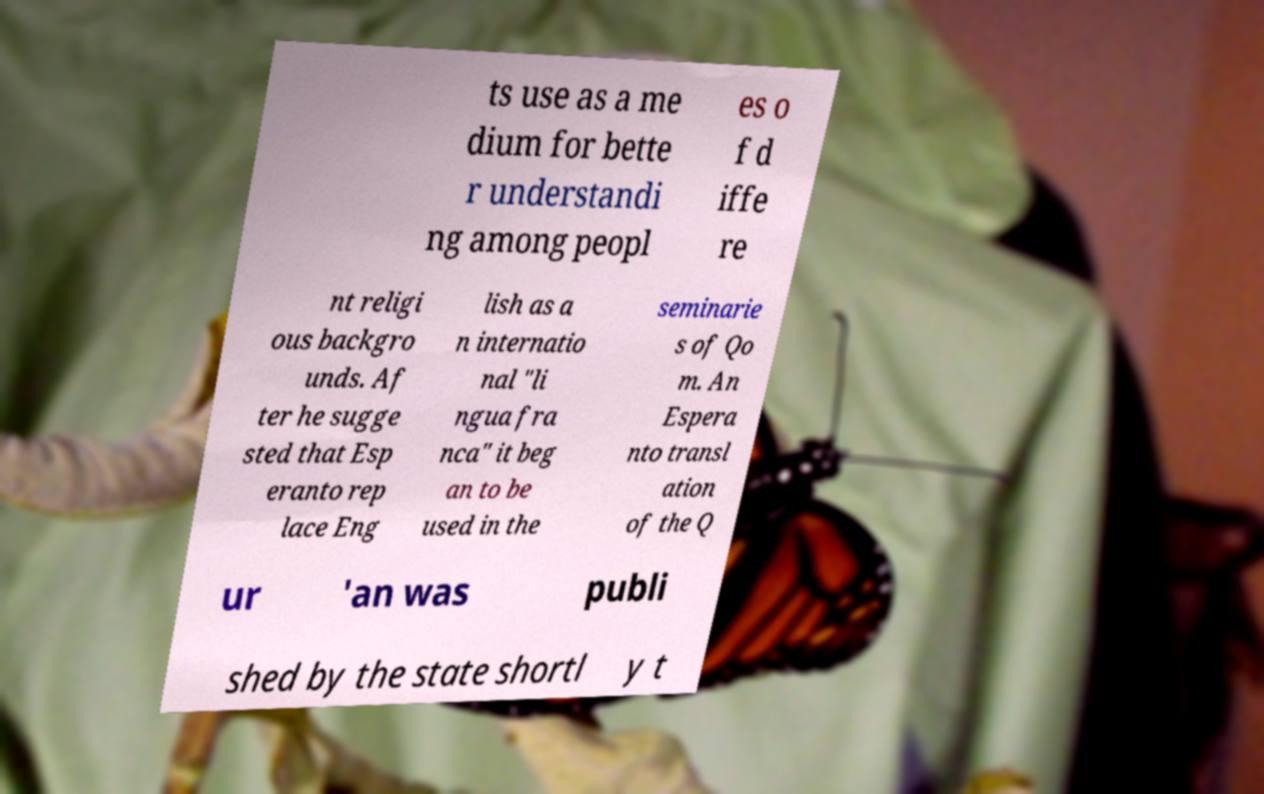There's text embedded in this image that I need extracted. Can you transcribe it verbatim? ts use as a me dium for bette r understandi ng among peopl es o f d iffe re nt religi ous backgro unds. Af ter he sugge sted that Esp eranto rep lace Eng lish as a n internatio nal "li ngua fra nca" it beg an to be used in the seminarie s of Qo m. An Espera nto transl ation of the Q ur 'an was publi shed by the state shortl y t 